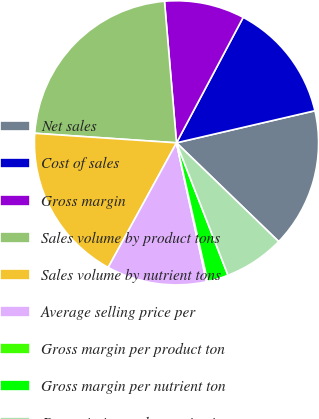<chart> <loc_0><loc_0><loc_500><loc_500><pie_chart><fcel>Net sales<fcel>Cost of sales<fcel>Gross margin<fcel>Sales volume by product tons<fcel>Sales volume by nutrient tons<fcel>Average selling price per<fcel>Gross margin per product ton<fcel>Gross margin per nutrient ton<fcel>Depreciation and amortization<nl><fcel>15.85%<fcel>13.6%<fcel>9.12%<fcel>22.58%<fcel>18.09%<fcel>11.36%<fcel>0.14%<fcel>2.38%<fcel>6.87%<nl></chart> 